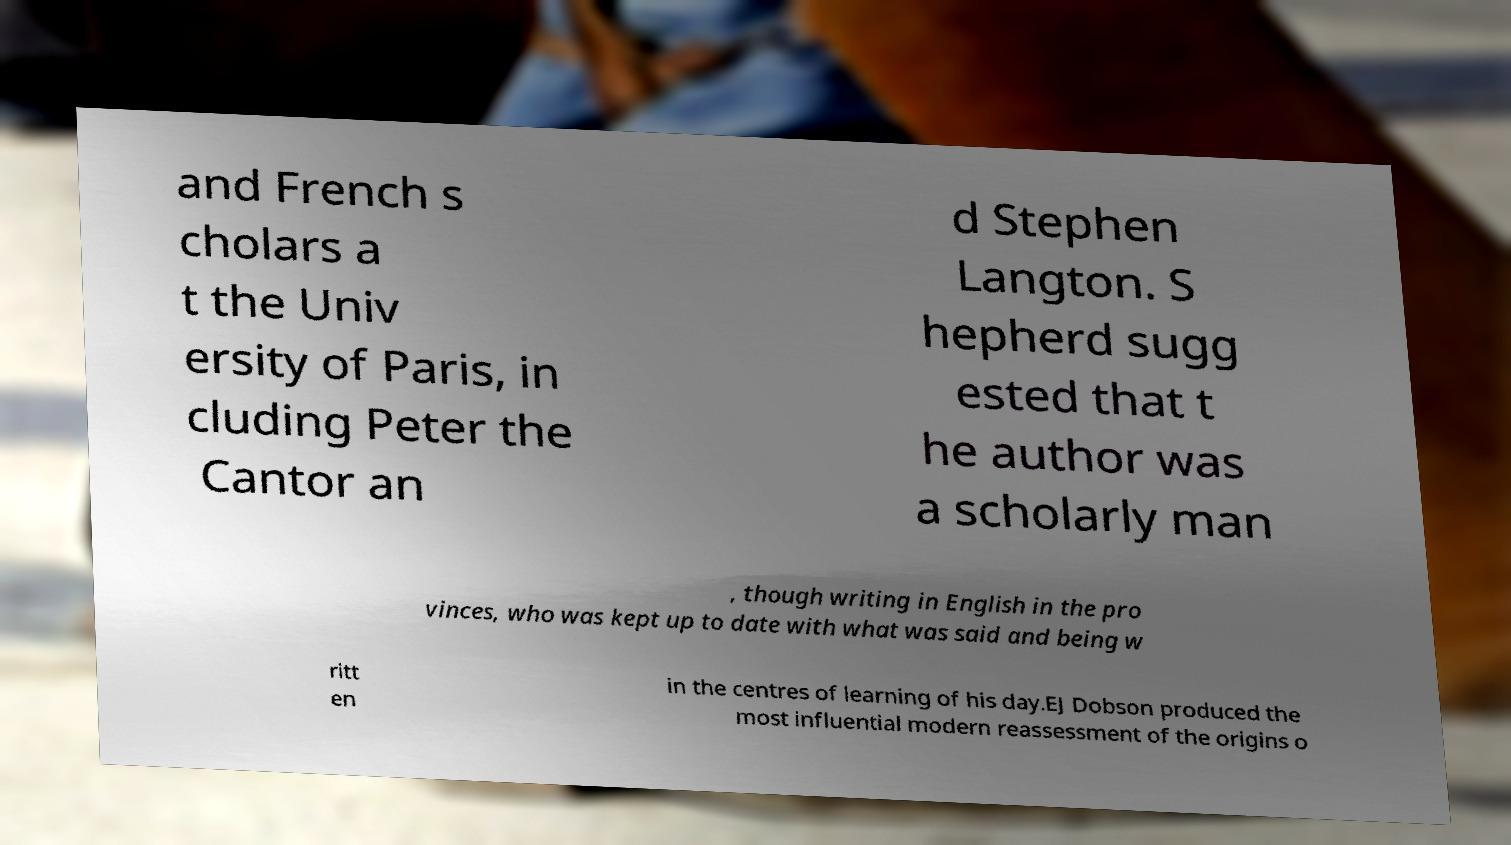Can you read and provide the text displayed in the image?This photo seems to have some interesting text. Can you extract and type it out for me? and French s cholars a t the Univ ersity of Paris, in cluding Peter the Cantor an d Stephen Langton. S hepherd sugg ested that t he author was a scholarly man , though writing in English in the pro vinces, who was kept up to date with what was said and being w ritt en in the centres of learning of his day.EJ Dobson produced the most influential modern reassessment of the origins o 